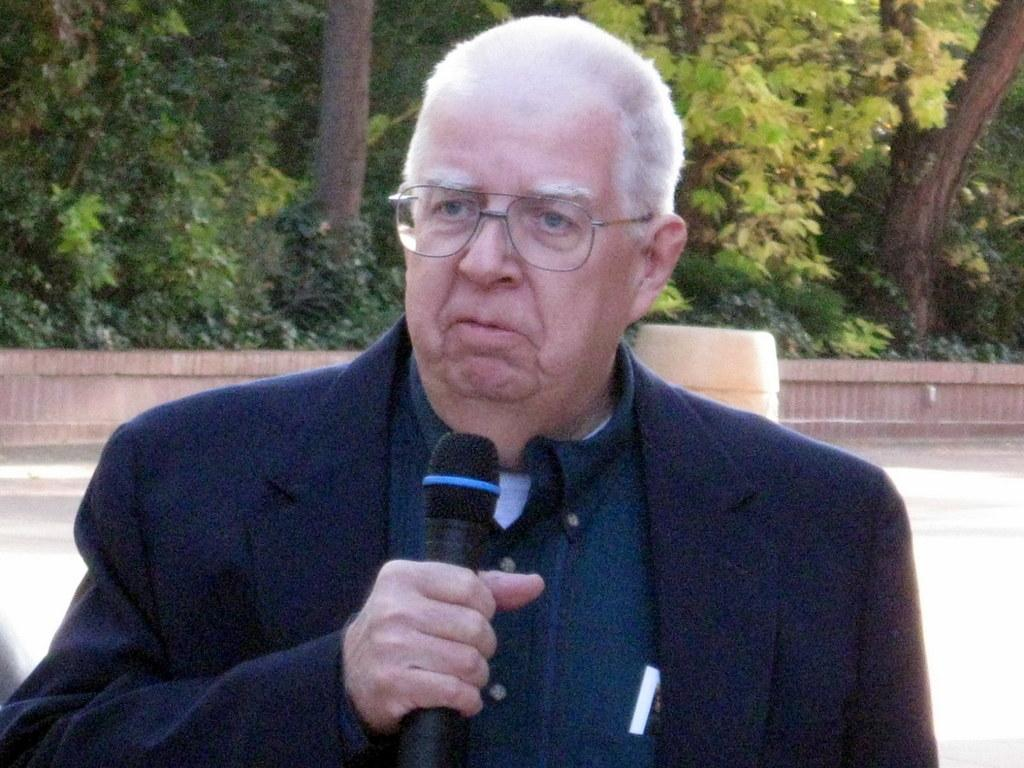What is the main subject of the image? There is a person in the image. What can be seen on the person's face? The person is wearing specs. What is the person holding in the image? The person is holding a mic. What can be seen in the background of the image? There is a wall and trees in the background of the image. How many zebras are visible in the image? There are no zebras present in the image. What type of committee is meeting in the image? There is no committee meeting in the image; it features a person holding a mic. 